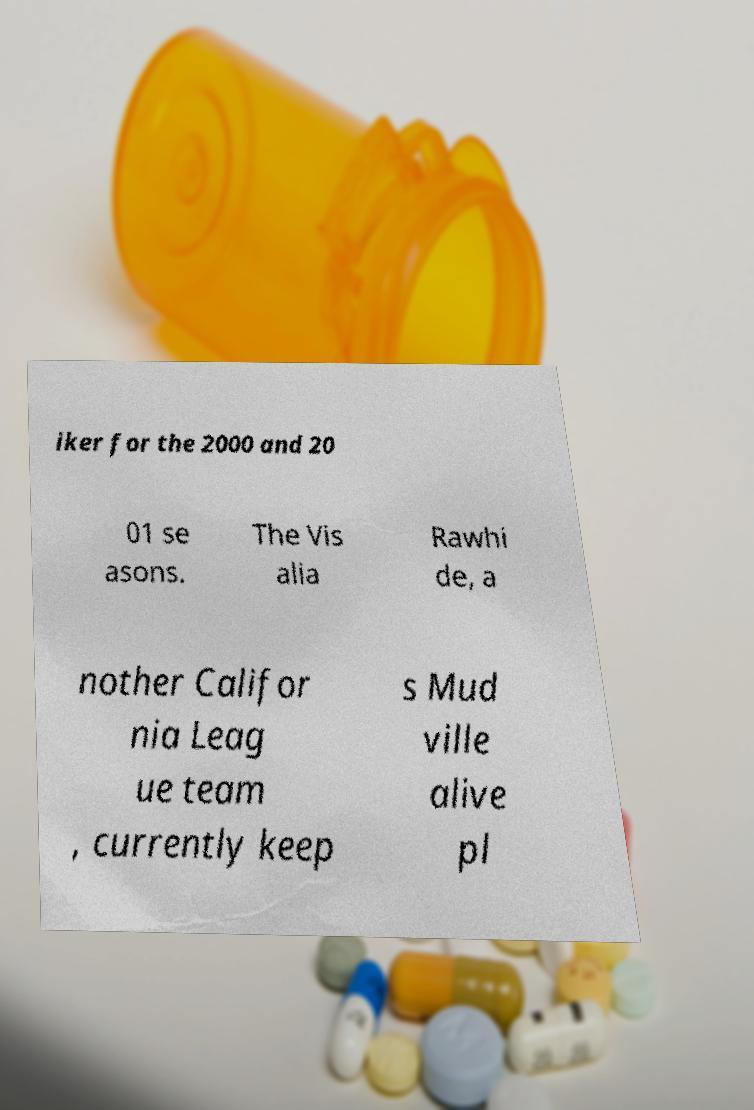Can you read and provide the text displayed in the image?This photo seems to have some interesting text. Can you extract and type it out for me? iker for the 2000 and 20 01 se asons. The Vis alia Rawhi de, a nother Califor nia Leag ue team , currently keep s Mud ville alive pl 